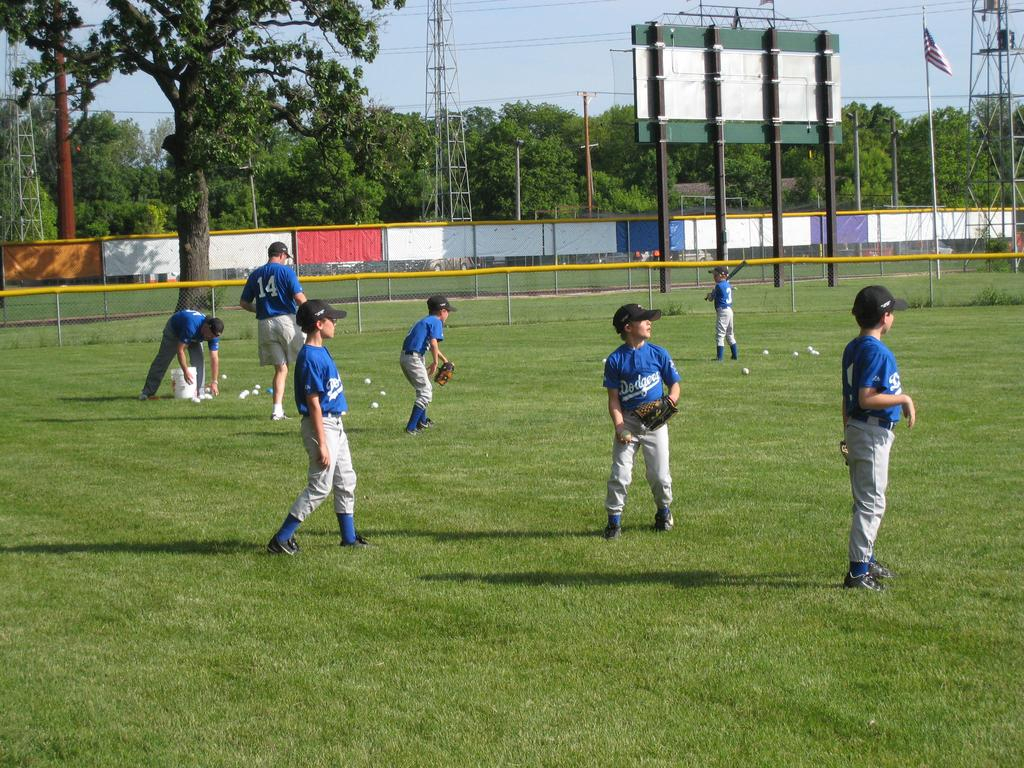Provide a one-sentence caption for the provided image. Boys playing baseball on the field in blue Dodgers jerseys. 